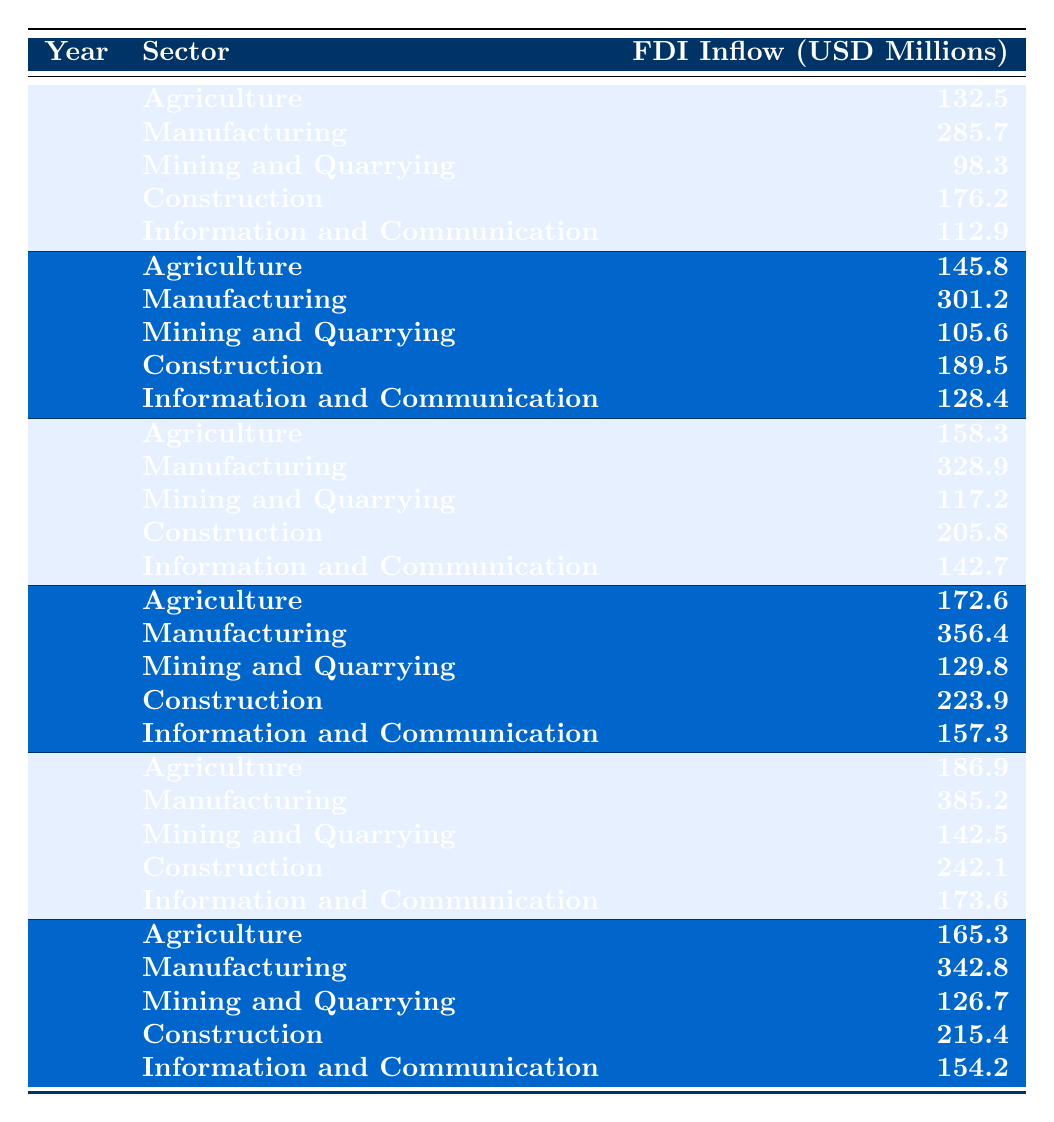What was the FDI inflow in the Manufacturing sector in 2019? The table shows the FDI inflow for the Manufacturing sector in 2019 as 385.2 million USD.
Answer: 385.2 million USD Which year had the highest FDI inflow in the Construction sector? By looking at the data, the highest FDI inflow for Construction occurred in 2019 with 242.1 million USD.
Answer: 2019 What is the total FDI inflow for Agriculture from 2015 to 2020? The total FDI for Agriculture can be calculated as follows: 132.5 + 145.8 + 158.3 + 172.6 + 186.9 + 165.3 = 1,021.4 million USD.
Answer: 1,021.4 million USD Did the FDI inflow in Mining and Quarrying increase from 2015 to 2019? By examining the values: 98.3 (2015), 105.6 (2016), 117.2 (2017), 129.8 (2018), and 142.5 (2019), we can see that it did increase each year, confirming it was true.
Answer: Yes What was the average FDI inflow in the Information and Communication sector from 2015 to 2020? To find this, sum the inflows: 112.9 + 128.4 + 142.7 + 157.3 + 173.6 + 154.2 = 869.1 million USD; then divide by 6 (the number of years) gives an average of 144.85 million USD.
Answer: 144.85 million USD Was the FDI inflow in the Mining and Quarrying sector lower in 2020 compared to 2015? In 2015, the inflow was 98.3 million USD, and in 2020 it was 126.7 million USD, which shows it was higher in 2020.
Answer: No What is the trend of FDI inflows in Manufacturing from 2015 to 2020? The FDI inflow for Manufacturing increased each year from 285.7 million (2015) to 342.8 million (2020), indicating a positive trend.
Answer: Increasing Which sector received the second highest FDI inflow in 2016? In 2016, the sector with the second highest inflow is Manufacturing with 301.2 million USD, after Agriculture.
Answer: Manufacturing What is the difference in FDI inflow for Agriculture between 2018 and 2019? The FDI inflow for Agriculture in 2018 was 172.6 million USD and in 2019 was 186.9 million USD; the difference is calculated as 186.9 - 172.6 = 14.3 million USD.
Answer: 14.3 million USD How did the FDI inflow in the Construction sector change from 2015 to 2020? The inflow for Construction was 176.2 million USD in 2015 and increased to 215.4 million USD in 2020, showing growth over the years.
Answer: Increased 